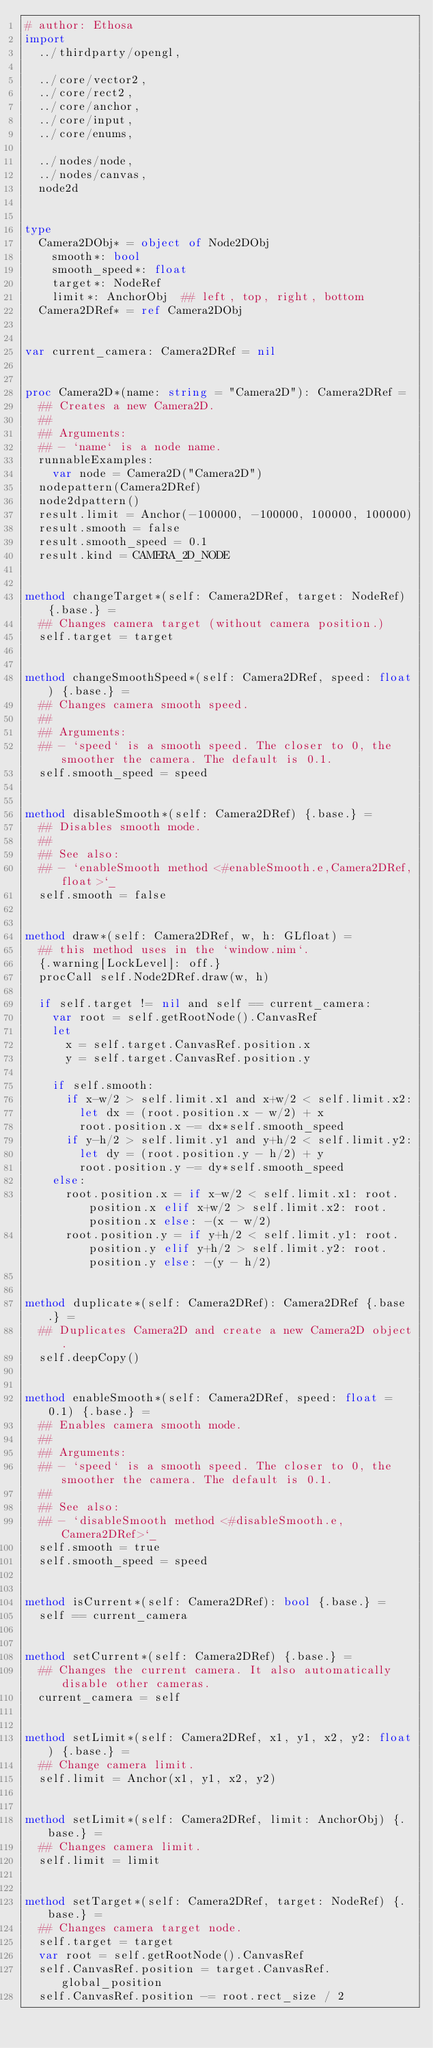<code> <loc_0><loc_0><loc_500><loc_500><_Nim_># author: Ethosa
import
  ../thirdparty/opengl,

  ../core/vector2,
  ../core/rect2,
  ../core/anchor,
  ../core/input,
  ../core/enums,

  ../nodes/node,
  ../nodes/canvas,
  node2d


type
  Camera2DObj* = object of Node2DObj
    smooth*: bool
    smooth_speed*: float
    target*: NodeRef
    limit*: AnchorObj  ## left, top, right, bottom
  Camera2DRef* = ref Camera2DObj


var current_camera: Camera2DRef = nil


proc Camera2D*(name: string = "Camera2D"): Camera2DRef =
  ## Creates a new Camera2D.
  ##
  ## Arguments:
  ## - `name` is a node name.
  runnableExamples:
    var node = Camera2D("Camera2D")
  nodepattern(Camera2DRef)
  node2dpattern()
  result.limit = Anchor(-100000, -100000, 100000, 100000)
  result.smooth = false
  result.smooth_speed = 0.1
  result.kind = CAMERA_2D_NODE


method changeTarget*(self: Camera2DRef, target: NodeRef) {.base.} =
  ## Changes camera target (without camera position.)
  self.target = target


method changeSmoothSpeed*(self: Camera2DRef, speed: float) {.base.} =
  ## Changes camera smooth speed.
  ##
  ## Arguments:
  ## - `speed` is a smooth speed. The closer to 0, the smoother the camera. The default is 0.1.
  self.smooth_speed = speed


method disableSmooth*(self: Camera2DRef) {.base.} =
  ## Disables smooth mode.
  ##
  ## See also:
  ## - `enableSmooth method <#enableSmooth.e,Camera2DRef,float>`_
  self.smooth = false


method draw*(self: Camera2DRef, w, h: GLfloat) =
  ## this method uses in the `window.nim`.
  {.warning[LockLevel]: off.}
  procCall self.Node2DRef.draw(w, h)

  if self.target != nil and self == current_camera:
    var root = self.getRootNode().CanvasRef
    let
      x = self.target.CanvasRef.position.x
      y = self.target.CanvasRef.position.y

    if self.smooth:
      if x-w/2 > self.limit.x1 and x+w/2 < self.limit.x2:
        let dx = (root.position.x - w/2) + x
        root.position.x -= dx*self.smooth_speed
      if y-h/2 > self.limit.y1 and y+h/2 < self.limit.y2:
        let dy = (root.position.y - h/2) + y
        root.position.y -= dy*self.smooth_speed
    else:
      root.position.x = if x-w/2 < self.limit.x1: root.position.x elif x+w/2 > self.limit.x2: root.position.x else: -(x - w/2)
      root.position.y = if y+h/2 < self.limit.y1: root.position.y elif y+h/2 > self.limit.y2: root.position.y else: -(y - h/2)


method duplicate*(self: Camera2DRef): Camera2DRef {.base.} =
  ## Duplicates Camera2D and create a new Camera2D object.
  self.deepCopy()


method enableSmooth*(self: Camera2DRef, speed: float = 0.1) {.base.} =
  ## Enables camera smooth mode.
  ##
  ## Arguments:
  ## - `speed` is a smooth speed. The closer to 0, the smoother the camera. The default is 0.1.
  ##
  ## See also:
  ## - `disableSmooth method <#disableSmooth.e,Camera2DRef>`_
  self.smooth = true
  self.smooth_speed = speed


method isCurrent*(self: Camera2DRef): bool {.base.} =
  self == current_camera


method setCurrent*(self: Camera2DRef) {.base.} =
  ## Changes the current camera. It also automatically disable other cameras.
  current_camera = self


method setLimit*(self: Camera2DRef, x1, y1, x2, y2: float) {.base.} =
  ## Change camera limit.
  self.limit = Anchor(x1, y1, x2, y2)


method setLimit*(self: Camera2DRef, limit: AnchorObj) {.base.} =
  ## Changes camera limit.
  self.limit = limit


method setTarget*(self: Camera2DRef, target: NodeRef) {.base.} =
  ## Changes camera target node.
  self.target = target
  var root = self.getRootNode().CanvasRef
  self.CanvasRef.position = target.CanvasRef.global_position
  self.CanvasRef.position -= root.rect_size / 2
</code> 